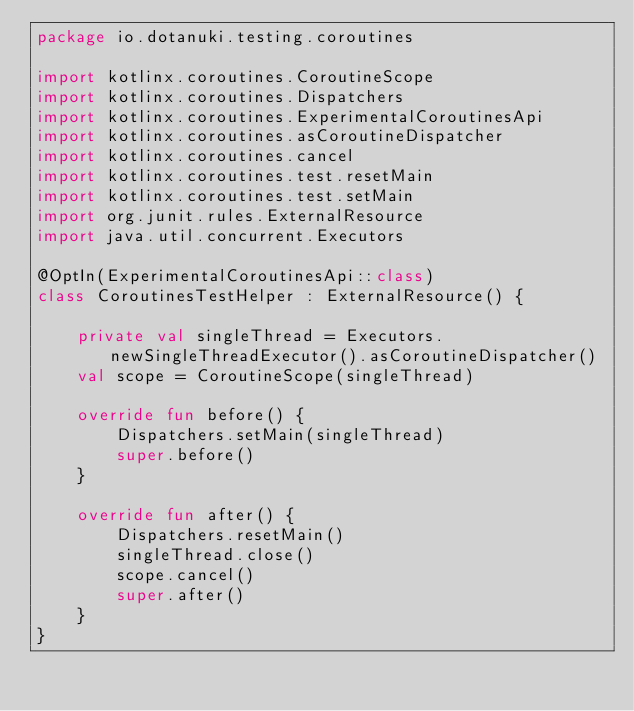<code> <loc_0><loc_0><loc_500><loc_500><_Kotlin_>package io.dotanuki.testing.coroutines

import kotlinx.coroutines.CoroutineScope
import kotlinx.coroutines.Dispatchers
import kotlinx.coroutines.ExperimentalCoroutinesApi
import kotlinx.coroutines.asCoroutineDispatcher
import kotlinx.coroutines.cancel
import kotlinx.coroutines.test.resetMain
import kotlinx.coroutines.test.setMain
import org.junit.rules.ExternalResource
import java.util.concurrent.Executors

@OptIn(ExperimentalCoroutinesApi::class)
class CoroutinesTestHelper : ExternalResource() {

    private val singleThread = Executors.newSingleThreadExecutor().asCoroutineDispatcher()
    val scope = CoroutineScope(singleThread)

    override fun before() {
        Dispatchers.setMain(singleThread)
        super.before()
    }

    override fun after() {
        Dispatchers.resetMain()
        singleThread.close()
        scope.cancel()
        super.after()
    }
}
</code> 